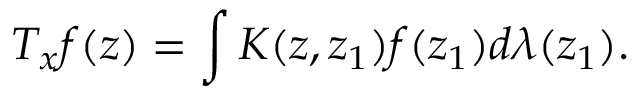<formula> <loc_0><loc_0><loc_500><loc_500>T _ { x } f ( z ) = \int K ( z , z _ { 1 } ) f ( z _ { 1 } ) d \lambda ( z _ { 1 } ) .</formula> 